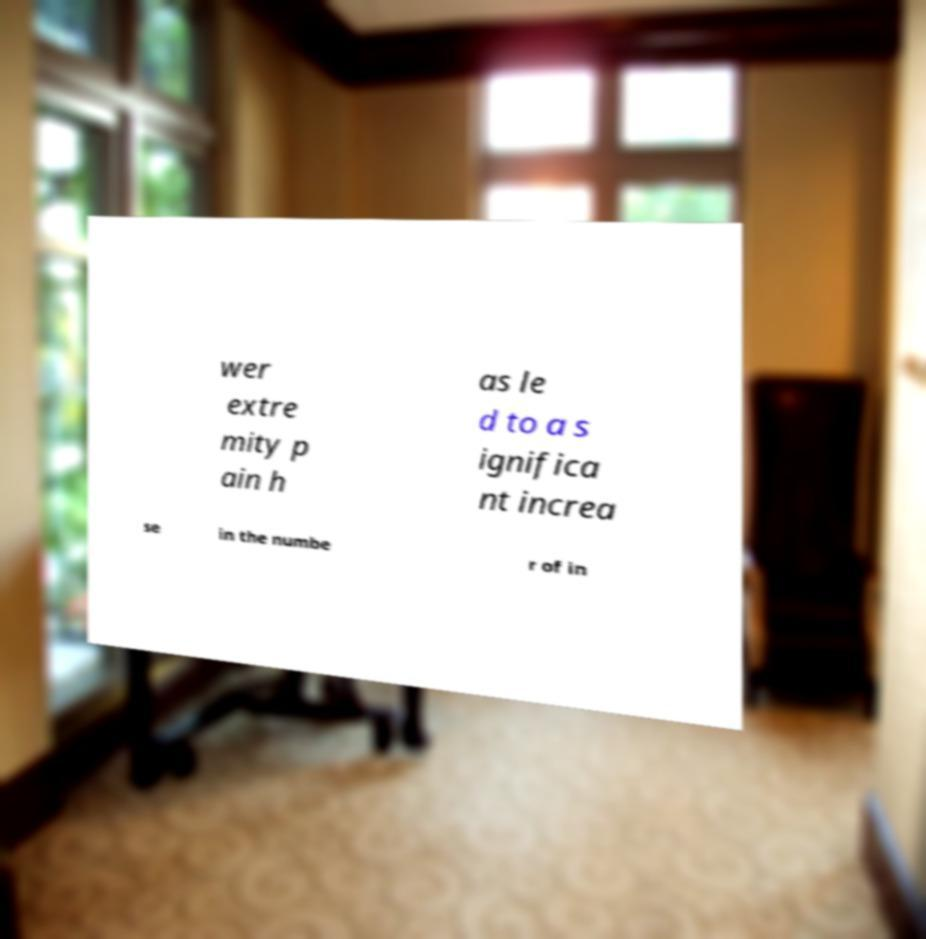Can you accurately transcribe the text from the provided image for me? wer extre mity p ain h as le d to a s ignifica nt increa se in the numbe r of in 